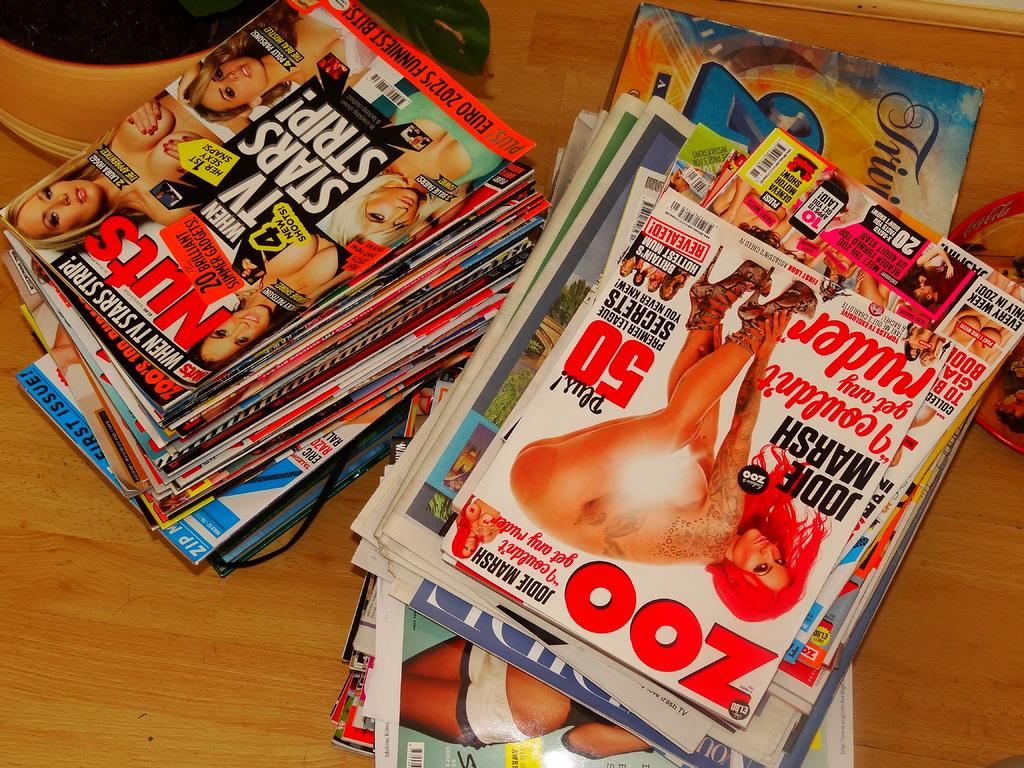<image>
Present a compact description of the photo's key features. A large pile of lads mags with Zoo being ontop. 